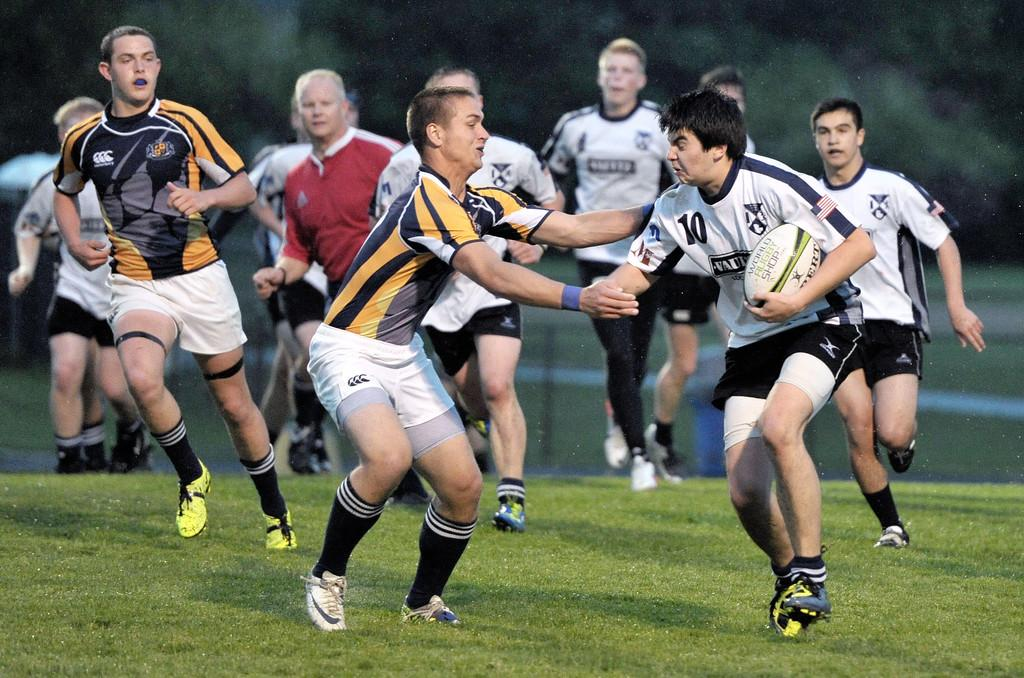What activity are the people in the image engaged in? The people in the image are playing a game. What object is being held by the person on the left side of the image? A ball is in the person's hand on the left side of the image. What type of surface is visible at the bottom of the image? There is grass at the bottom of the image. What can be seen in the background of the image? There are trees in the background of the image. What type of cannon is being used to shoot the ball in the image? There is no cannon present in the image; the people are playing a game without any cannons. How many bikes are visible in the image? There are no bikes present in the image; the focus is on the people playing a game. 